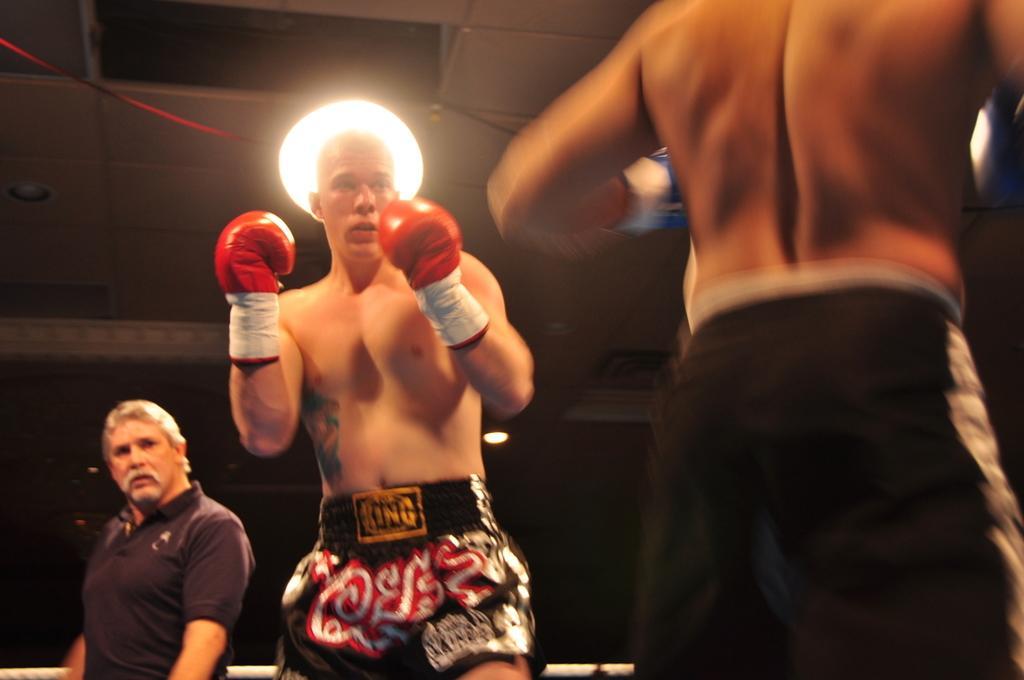Can you describe this image briefly? In this image we can see a person wearing gloves. In the back there is another person. Also there is light. In the background it is dark. 